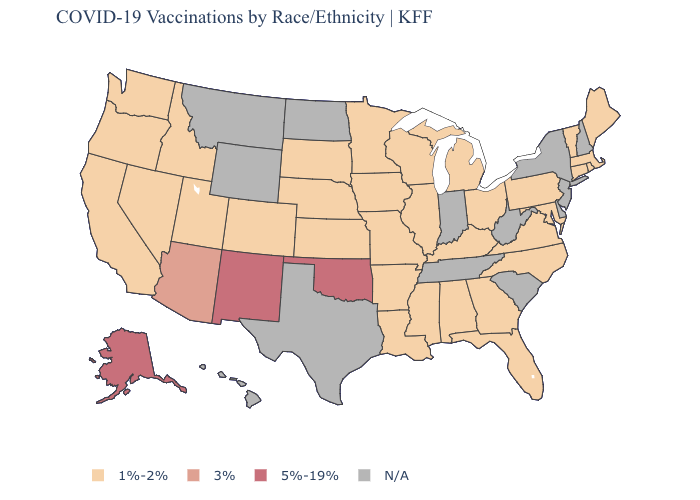Does the first symbol in the legend represent the smallest category?
Be succinct. Yes. What is the value of Arkansas?
Concise answer only. 1%-2%. What is the lowest value in the MidWest?
Be succinct. 1%-2%. Name the states that have a value in the range 1%-2%?
Quick response, please. Alabama, Arkansas, California, Colorado, Connecticut, Florida, Georgia, Idaho, Illinois, Iowa, Kansas, Kentucky, Louisiana, Maine, Maryland, Massachusetts, Michigan, Minnesota, Mississippi, Missouri, Nebraska, Nevada, North Carolina, Ohio, Oregon, Pennsylvania, Rhode Island, South Dakota, Utah, Vermont, Virginia, Washington, Wisconsin. Among the states that border Delaware , which have the lowest value?
Give a very brief answer. Maryland, Pennsylvania. Name the states that have a value in the range 5%-19%?
Keep it brief. Alaska, New Mexico, Oklahoma. Does the map have missing data?
Answer briefly. Yes. Among the states that border Oklahoma , does New Mexico have the highest value?
Be succinct. Yes. What is the value of Idaho?
Give a very brief answer. 1%-2%. Name the states that have a value in the range 1%-2%?
Concise answer only. Alabama, Arkansas, California, Colorado, Connecticut, Florida, Georgia, Idaho, Illinois, Iowa, Kansas, Kentucky, Louisiana, Maine, Maryland, Massachusetts, Michigan, Minnesota, Mississippi, Missouri, Nebraska, Nevada, North Carolina, Ohio, Oregon, Pennsylvania, Rhode Island, South Dakota, Utah, Vermont, Virginia, Washington, Wisconsin. What is the highest value in the USA?
Be succinct. 5%-19%. Name the states that have a value in the range N/A?
Be succinct. Delaware, Hawaii, Indiana, Montana, New Hampshire, New Jersey, New York, North Dakota, South Carolina, Tennessee, Texas, West Virginia, Wyoming. 